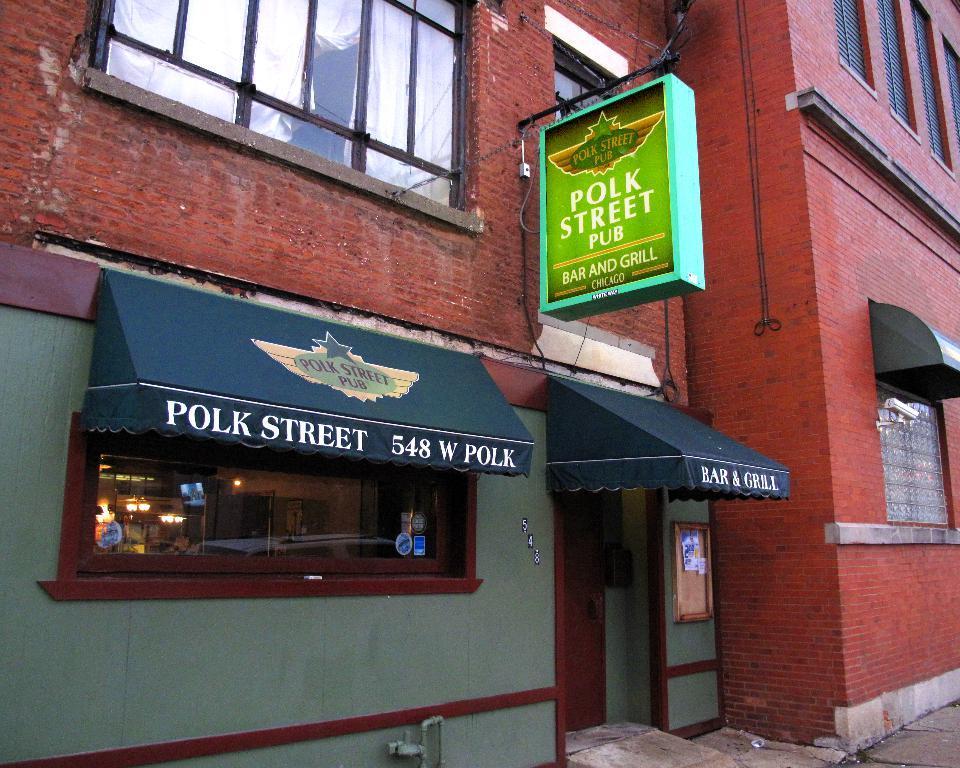In one or two sentences, can you explain what this image depicts? In this image we can see a building, there are some windows, door and a board with some text, through the glass we can see some objects. 